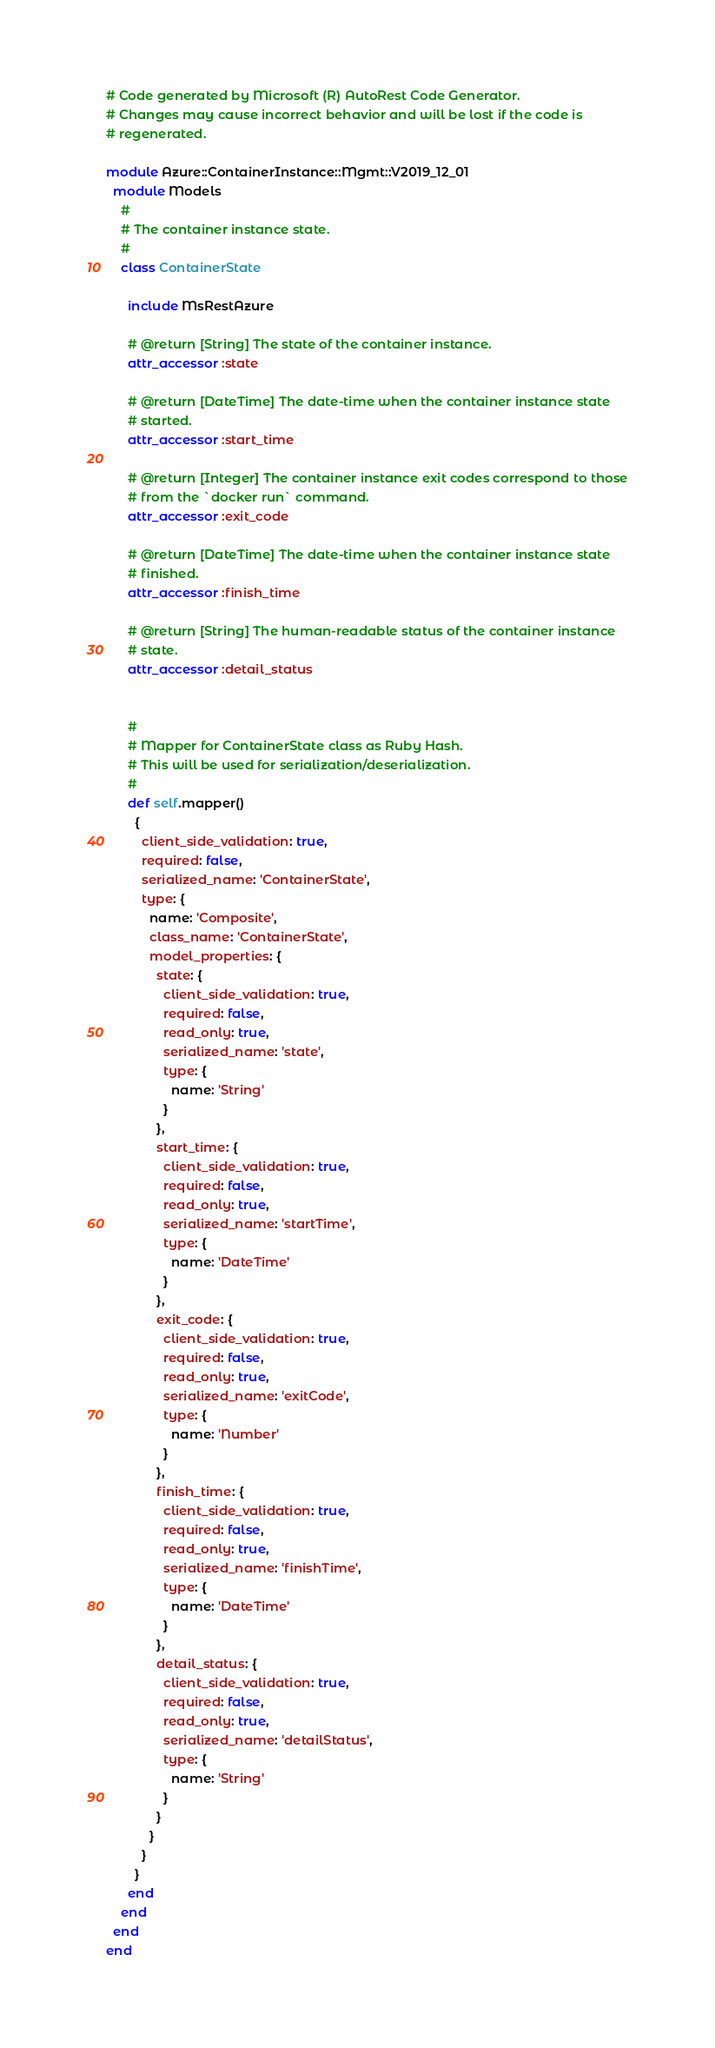Convert code to text. <code><loc_0><loc_0><loc_500><loc_500><_Ruby_># Code generated by Microsoft (R) AutoRest Code Generator.
# Changes may cause incorrect behavior and will be lost if the code is
# regenerated.

module Azure::ContainerInstance::Mgmt::V2019_12_01
  module Models
    #
    # The container instance state.
    #
    class ContainerState

      include MsRestAzure

      # @return [String] The state of the container instance.
      attr_accessor :state

      # @return [DateTime] The date-time when the container instance state
      # started.
      attr_accessor :start_time

      # @return [Integer] The container instance exit codes correspond to those
      # from the `docker run` command.
      attr_accessor :exit_code

      # @return [DateTime] The date-time when the container instance state
      # finished.
      attr_accessor :finish_time

      # @return [String] The human-readable status of the container instance
      # state.
      attr_accessor :detail_status


      #
      # Mapper for ContainerState class as Ruby Hash.
      # This will be used for serialization/deserialization.
      #
      def self.mapper()
        {
          client_side_validation: true,
          required: false,
          serialized_name: 'ContainerState',
          type: {
            name: 'Composite',
            class_name: 'ContainerState',
            model_properties: {
              state: {
                client_side_validation: true,
                required: false,
                read_only: true,
                serialized_name: 'state',
                type: {
                  name: 'String'
                }
              },
              start_time: {
                client_side_validation: true,
                required: false,
                read_only: true,
                serialized_name: 'startTime',
                type: {
                  name: 'DateTime'
                }
              },
              exit_code: {
                client_side_validation: true,
                required: false,
                read_only: true,
                serialized_name: 'exitCode',
                type: {
                  name: 'Number'
                }
              },
              finish_time: {
                client_side_validation: true,
                required: false,
                read_only: true,
                serialized_name: 'finishTime',
                type: {
                  name: 'DateTime'
                }
              },
              detail_status: {
                client_side_validation: true,
                required: false,
                read_only: true,
                serialized_name: 'detailStatus',
                type: {
                  name: 'String'
                }
              }
            }
          }
        }
      end
    end
  end
end
</code> 